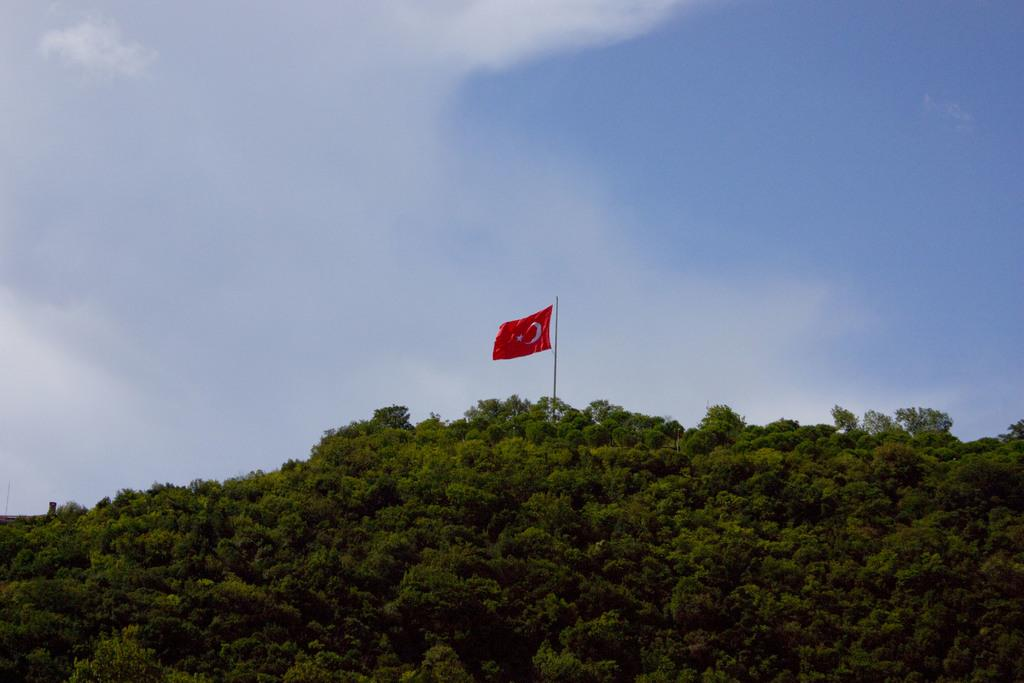What is the main feature of the image? There is a mountain in the image. What can be seen on the mountain? There are trees and a flag on the mountain. What is visible in the background of the image? The sky is visible in the background of the image. Who is the creator of the mountain in the image? The mountain is a natural formation and not created by any individual, so there is no specific creator. Are there any bubbles visible in the image? There are no bubbles present in the image. 